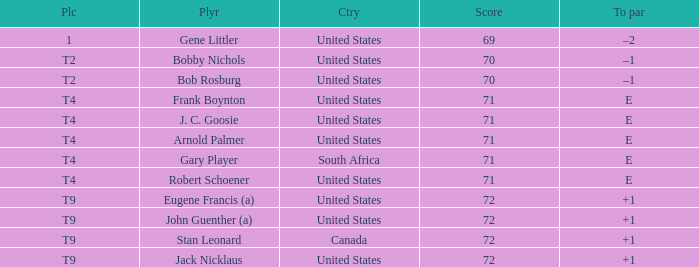What is To Par, when Country is "United States", when Place is "T4", and when Player is "Arnold Palmer"? E. I'm looking to parse the entire table for insights. Could you assist me with that? {'header': ['Plc', 'Plyr', 'Ctry', 'Score', 'To par'], 'rows': [['1', 'Gene Littler', 'United States', '69', '–2'], ['T2', 'Bobby Nichols', 'United States', '70', '–1'], ['T2', 'Bob Rosburg', 'United States', '70', '–1'], ['T4', 'Frank Boynton', 'United States', '71', 'E'], ['T4', 'J. C. Goosie', 'United States', '71', 'E'], ['T4', 'Arnold Palmer', 'United States', '71', 'E'], ['T4', 'Gary Player', 'South Africa', '71', 'E'], ['T4', 'Robert Schoener', 'United States', '71', 'E'], ['T9', 'Eugene Francis (a)', 'United States', '72', '+1'], ['T9', 'John Guenther (a)', 'United States', '72', '+1'], ['T9', 'Stan Leonard', 'Canada', '72', '+1'], ['T9', 'Jack Nicklaus', 'United States', '72', '+1']]} 